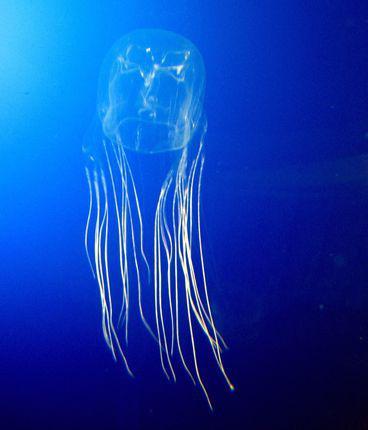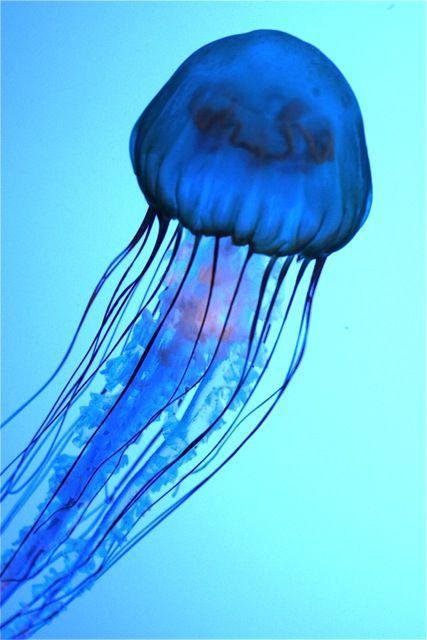The first image is the image on the left, the second image is the image on the right. For the images displayed, is the sentence "Two jellyfish are visible in the left image." factually correct? Answer yes or no. No. 